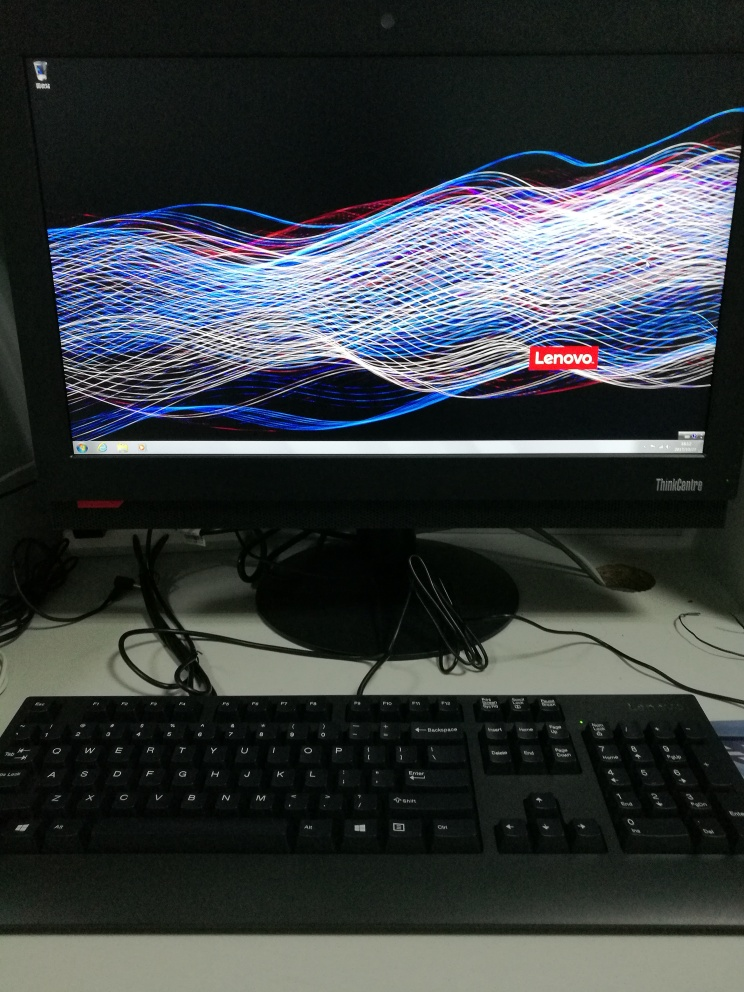What is the make and model of the computer shown? The computer is manufactured by Lenovo, as indicated by the logo on the monitor, but the specific model of the computer cannot be determined from the image alone without additional information. 